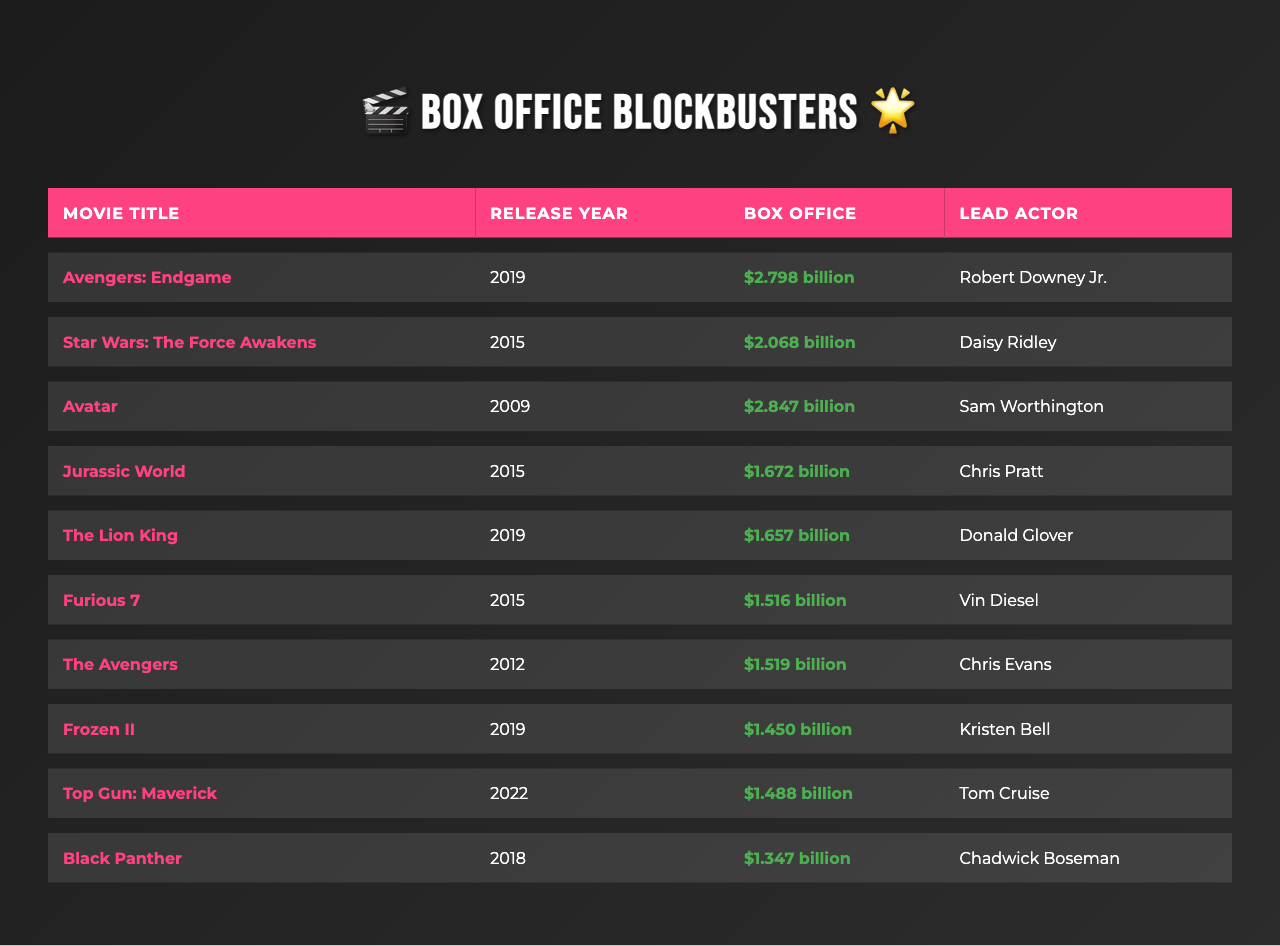What is the highest-grossing movie in the past decade? The highest-grossing movie is "Avengers: Endgame," which earned $2.798 billion at the box office.
Answer: Avengers: Endgame Which lead actor starred in "Frozen II"? The lead actor in "Frozen II" is Kristen Bell, according to the table data.
Answer: Kristen Bell How much did "The Lion King" earn at the box office? "The Lion King" earned $1.657 billion as shown in the table.
Answer: $1.657 billion Is "Avatar" the only movie released in 2009 on the list? Yes, "Avatar" is the only movie released in 2009, as no other movies from that year are listed.
Answer: Yes What is the combined box office revenue of the top three movies? The top three movies based on box office revenue are "Avengers: Endgame" ($2.798 billion), "Avatar" ($2.847 billion), and "Star Wars: The Force Awakens" ($2.068 billion), which adds up to $2.798 + $2.847 + $2.068 = $7.713 billion.
Answer: $7.713 billion How many movies feature Chris Pratt as the lead actor? Chris Pratt is the lead actor in only one movie on the list, which is "Jurassic World."
Answer: 1 Which movie has a box office total closest to $1.5 billion? "Top Gun: Maverick" has a box office total of $1.488 billion, making it the closest to $1.5 billion.
Answer: Top Gun: Maverick Are there any movies released in 2015 among the highest-grossing films? Yes, there are two movies from 2015: "Star Wars: The Force Awakens" and "Jurassic World."
Answer: Yes What is the average box office revenue of all the movies listed? The average box office is calculated as the total revenue of all movies divided by the number of movies. The total is $2.798 + $2.068 + $2.847 + $1.672 + $1.657 + $1.516 + $1.519 + $1.450 + $1.488 + $1.347 = $17.164 billion. Since there are 10 movies, the average is $17.164 billion / 10 = $1.7164 billion.
Answer: $1.7164 billion Which movie from the list has the lowest box office revenue? "Black Panther" has the lowest box office revenue on the list, earning $1.347 billion.
Answer: Black Panther 